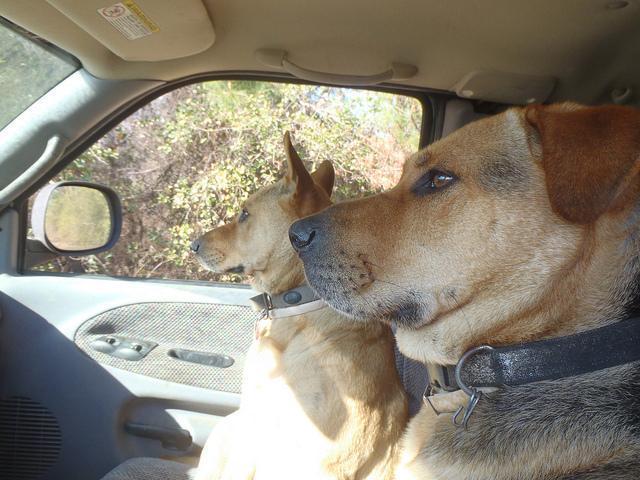How many dogs are in this scene?
Give a very brief answer. 2. How many dogs are there?
Give a very brief answer. 2. How many apples are on display?
Give a very brief answer. 0. 